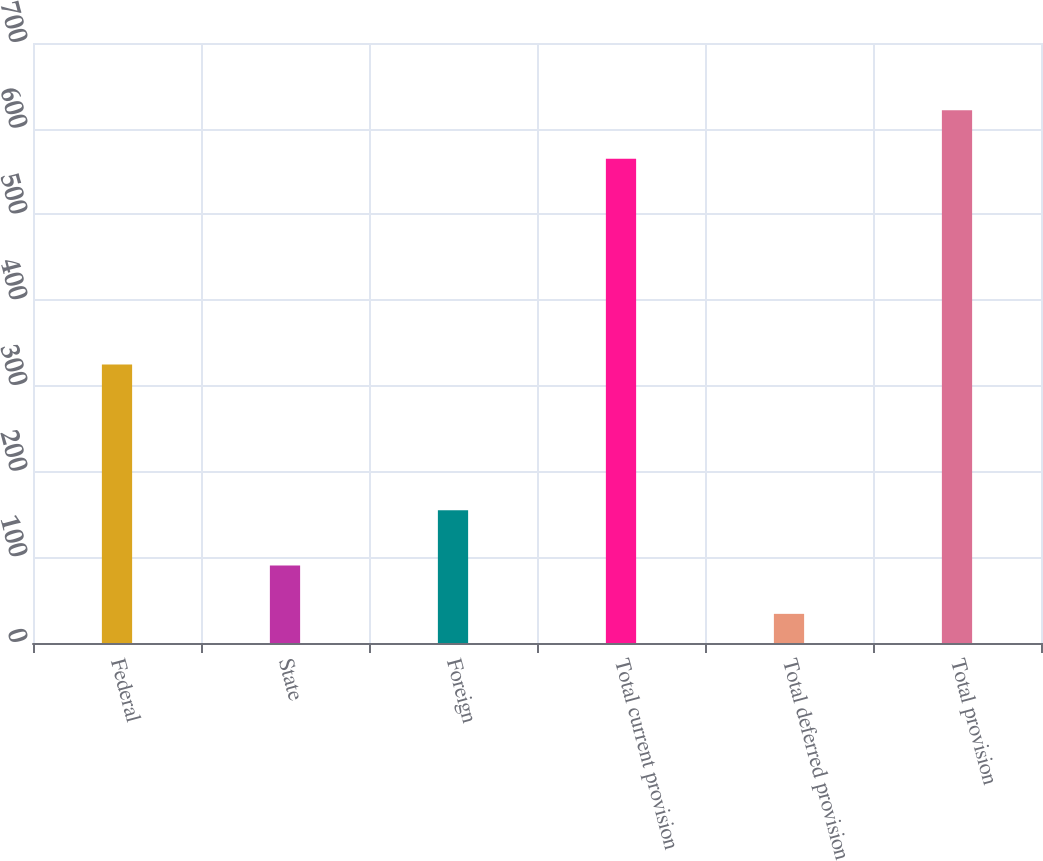Convert chart. <chart><loc_0><loc_0><loc_500><loc_500><bar_chart><fcel>Federal<fcel>State<fcel>Foreign<fcel>Total current provision<fcel>Total deferred provision<fcel>Total provision<nl><fcel>325<fcel>90.5<fcel>155<fcel>565<fcel>34<fcel>621.5<nl></chart> 